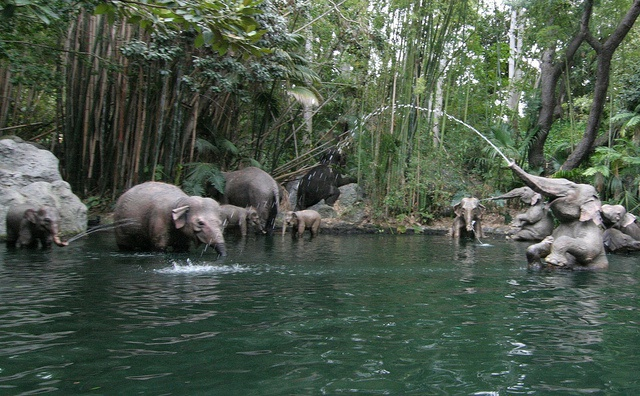Describe the objects in this image and their specific colors. I can see elephant in darkgreen, black, gray, and darkgray tones, elephant in darkgreen, darkgray, gray, lightgray, and black tones, elephant in darkgreen, gray, black, and teal tones, elephant in darkgreen, black, gray, and darkgray tones, and elephant in darkgreen, black, gray, and darkgray tones in this image. 